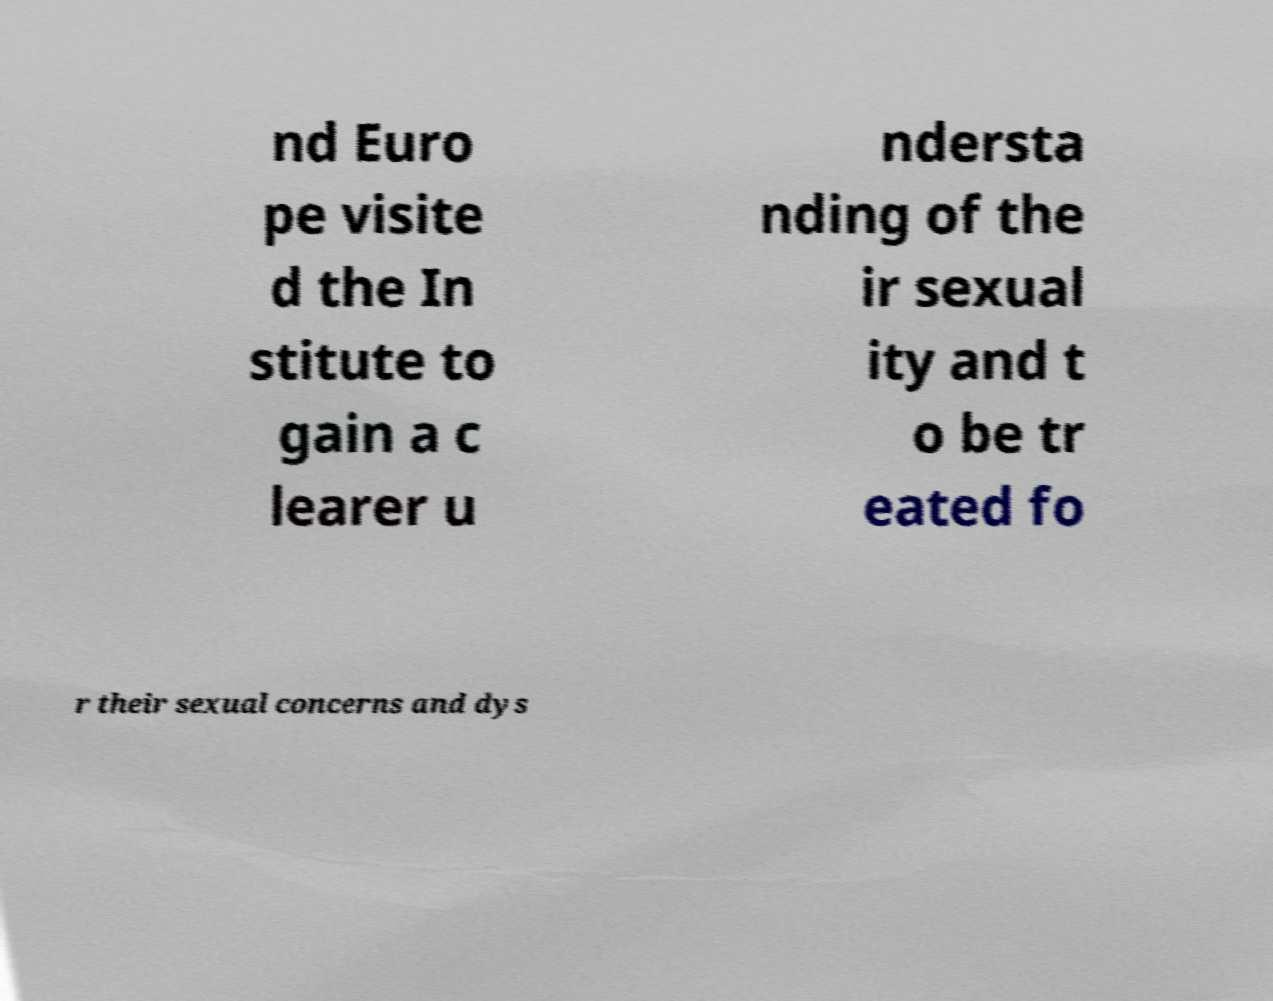Can you read and provide the text displayed in the image?This photo seems to have some interesting text. Can you extract and type it out for me? nd Euro pe visite d the In stitute to gain a c learer u ndersta nding of the ir sexual ity and t o be tr eated fo r their sexual concerns and dys 